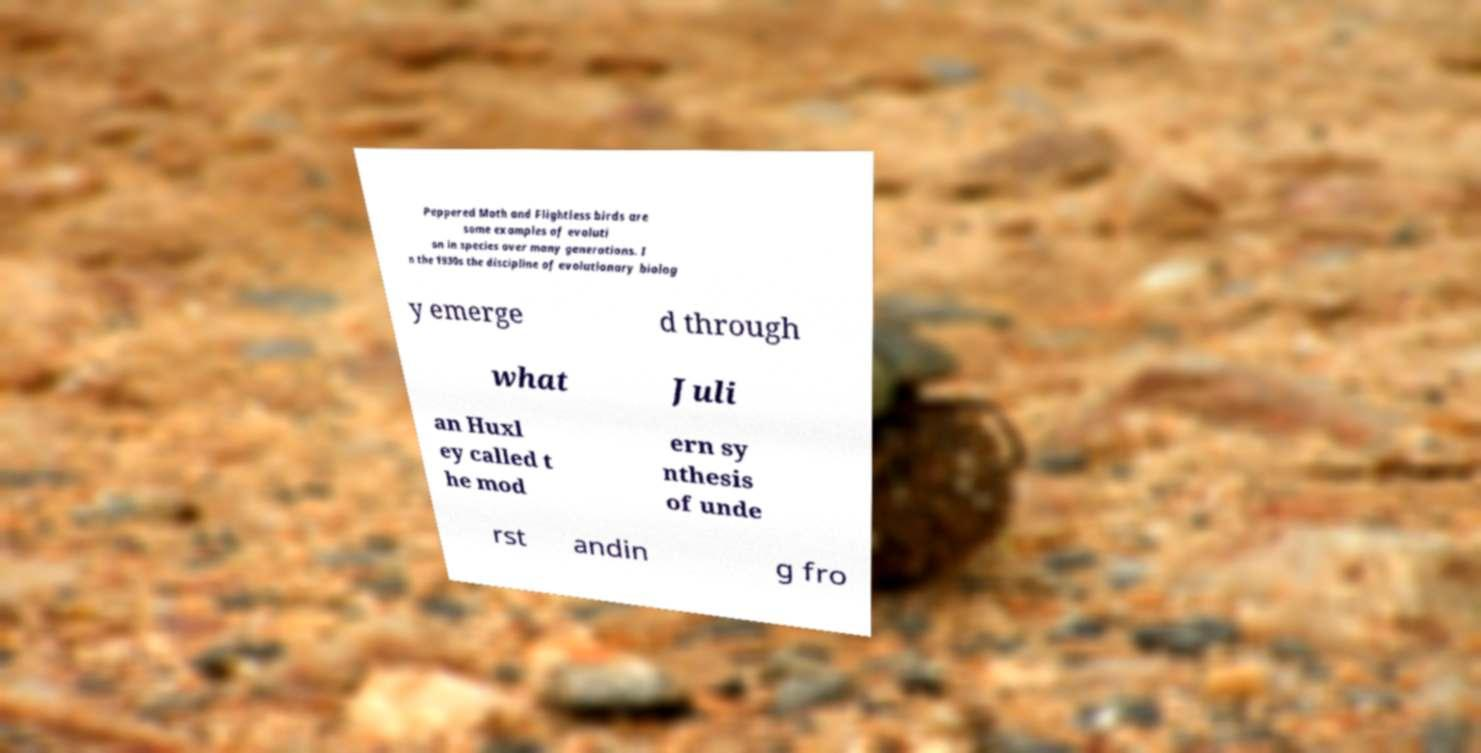Can you read and provide the text displayed in the image?This photo seems to have some interesting text. Can you extract and type it out for me? Peppered Moth and Flightless birds are some examples of evoluti on in species over many generations. I n the 1930s the discipline of evolutionary biolog y emerge d through what Juli an Huxl ey called t he mod ern sy nthesis of unde rst andin g fro 